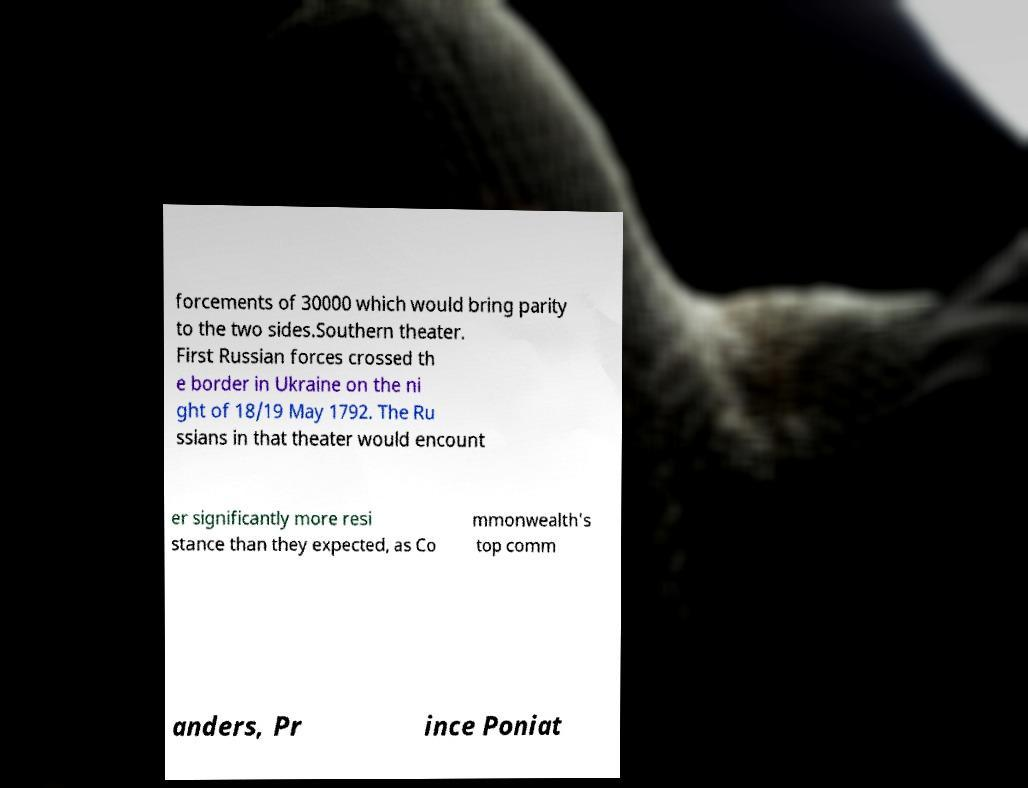Can you accurately transcribe the text from the provided image for me? forcements of 30000 which would bring parity to the two sides.Southern theater. First Russian forces crossed th e border in Ukraine on the ni ght of 18/19 May 1792. The Ru ssians in that theater would encount er significantly more resi stance than they expected, as Co mmonwealth's top comm anders, Pr ince Poniat 